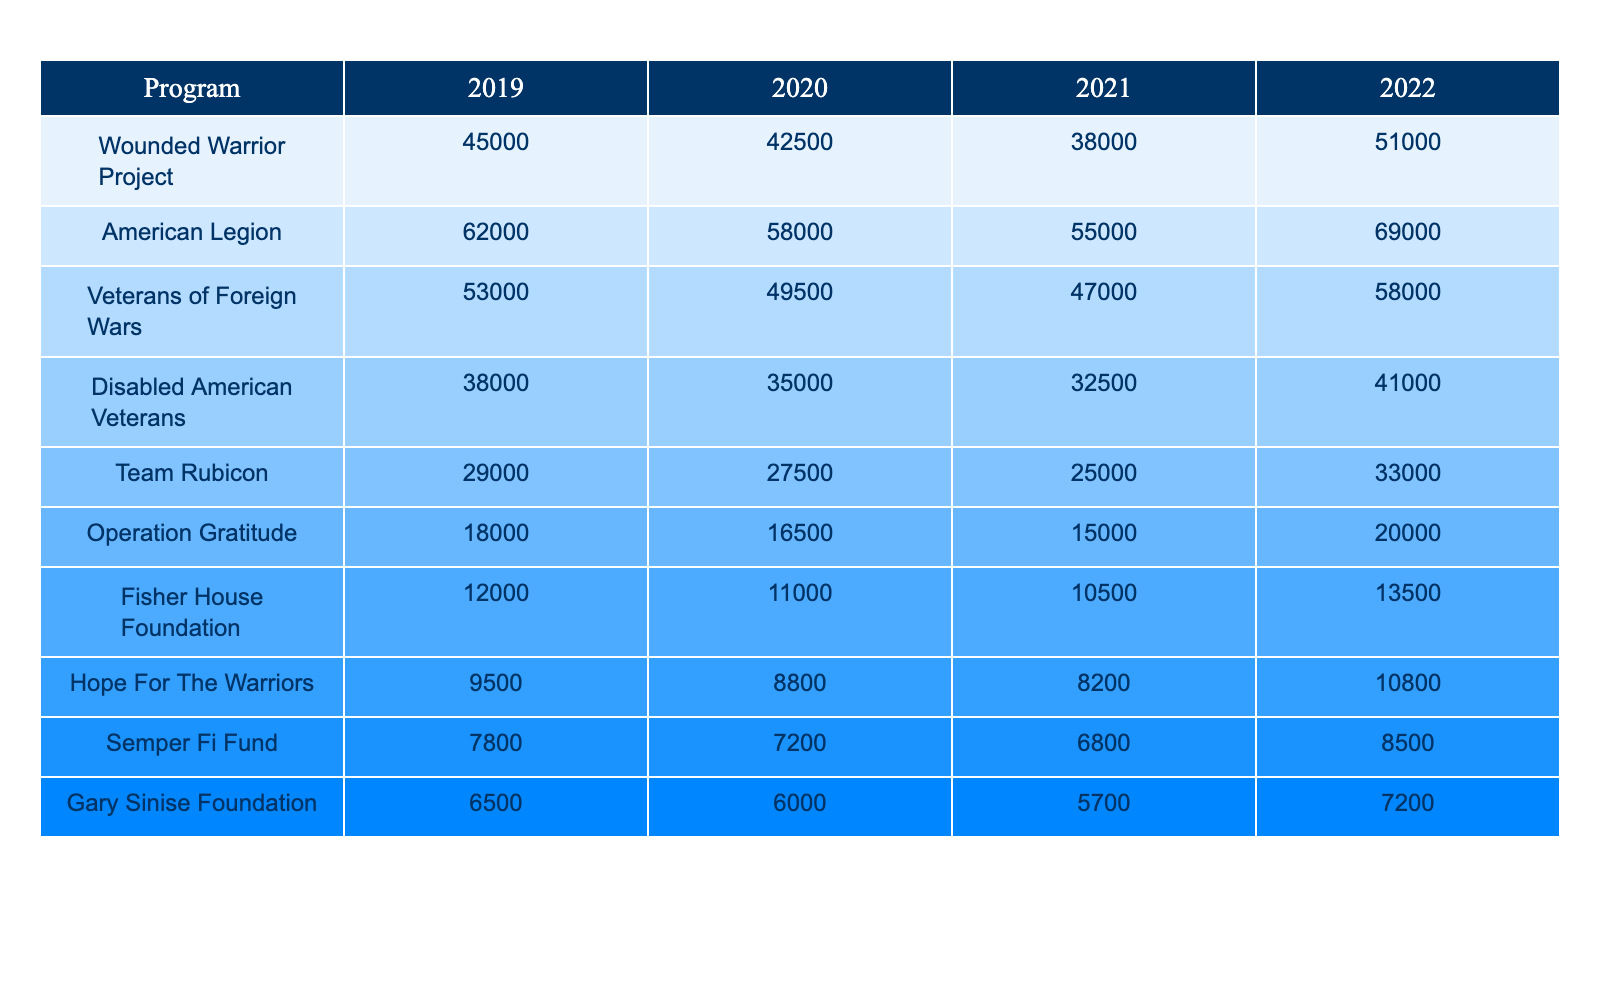What was the total volunteer hours logged by the American Legion in 2022? To find the total volunteer hours for the American Legion in 2022, we can simply read the table and locate the corresponding value, which is 69,000.
Answer: 69,000 Which program had the least volunteer hours in 2019? We can look at the data for 2019 and compare the values listed for each program. The program with the least hours is the Gary Sinise Foundation at 6,500.
Answer: Gary Sinise Foundation How much did the volunteer hours for Team Rubicon increase from 2021 to 2022? We subtract the hours logged in 2021 (25,000) from the hours logged in 2022 (33,000), resulting in an increase of 8,000.
Answer: 8,000 What is the average number of volunteer hours logged across all programs in 2020? We first sum the volunteer hours for all programs in 2020: 42,500 + 58,000 + 49,500 + 35,000 + 27,500 + 16,500 + 11,000 + 8,800 + 7,200 + 6,000 = 305,000. Then we divide by the total number of programs (10), yielding an average of 30,500.
Answer: 30,500 Did the total volunteer hours for Disabled American Veterans decline each year from 2019 to 2022? We can check the hours for each year: 38,000 in 2019, 35,000 in 2020, 32,500 in 2021, and 41,000 in 2022. Checking these indicates a decline initially, but there was an increase in 2022, so the answer is no.
Answer: No What is the difference in volunteer hours logged by Operation Gratitude between 2019 and 2022? We subtract the value for 2019 (18,000) from the value for 2022 (20,000), which gives us a difference of 2,000.
Answer: 2,000 If we consider the average volunteer hours logged by the top three programs in 2021, what is that average? The top three programs in 2021 by hours are: American Legion (55,000), Wounded Warrior Project (38,000), and Veterans of Foreign Wars (47,000). Adding these results gives us 140,000, and dividing by 3 gives an average of 46,667.
Answer: 46,667 Which program experienced the most significant increase in volunteer hours over the four years? We can look at the values for each program over the four years and calculate the differences: Wounded Warrior Project (6,000 increase), American Legion (7,000 increase), Disabled American Veterans (3,000 increase), etc. The greatest increase was found with the American Legion with a total increase of 7,000 hours from 2019 to 2022.
Answer: American Legion What was the total number of volunteer hours logged by all programs in 2020? To find this, we sum the volunteer hours for all programs in 2020: 42,500 + 58,000 + 49,500 + 35,000 + 27,500 + 16,500 + 11,000 + 8,800 + 7,200 + 6,000 which gives us a total of 305,000 volunteer hours.
Answer: 305,000 Was there any year in which the volunteer hours for the Semper Fi Fund exceeded 8,500? Check the values for the Semper Fi Fund across the years: 7,800 in 2019, 7,200 in 2020, 6,800 in 2021, and 8,500 in 2022. Based on these figures, 2022 is the only year the hours reached this number, confirming the statement is true.
Answer: Yes 